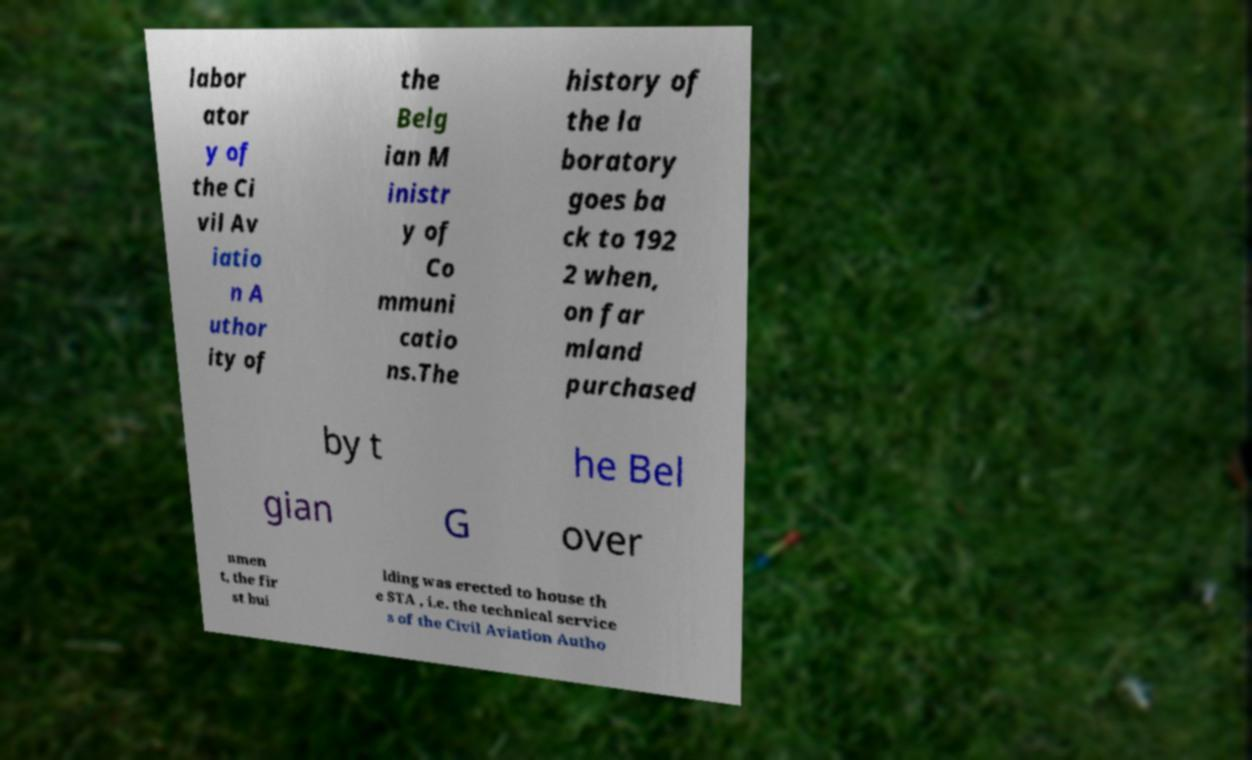There's text embedded in this image that I need extracted. Can you transcribe it verbatim? labor ator y of the Ci vil Av iatio n A uthor ity of the Belg ian M inistr y of Co mmuni catio ns.The history of the la boratory goes ba ck to 192 2 when, on far mland purchased by t he Bel gian G over nmen t, the fir st bui lding was erected to house th e STA , i.e. the technical service s of the Civil Aviation Autho 